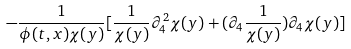Convert formula to latex. <formula><loc_0><loc_0><loc_500><loc_500>- \frac { 1 } { \phi ( t , x ) \chi ( y ) } [ \frac { 1 } { \chi ( y ) } \partial _ { 4 } ^ { 2 } \chi ( y ) + ( \partial _ { 4 } \frac { 1 } { \chi ( y ) } ) \partial _ { 4 } \chi ( y ) ]</formula> 